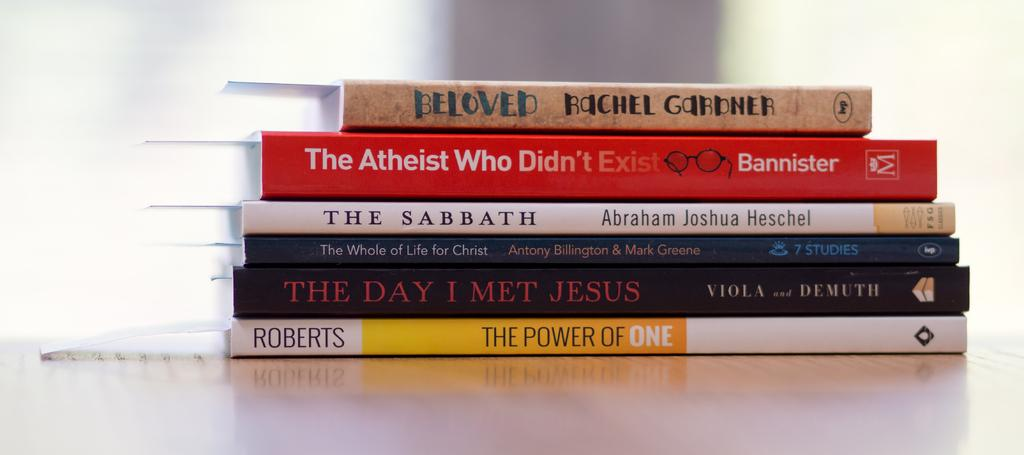<image>
Summarize the visual content of the image. stack of books including beloved, the atheist who didn't exist, and the sabbeth 